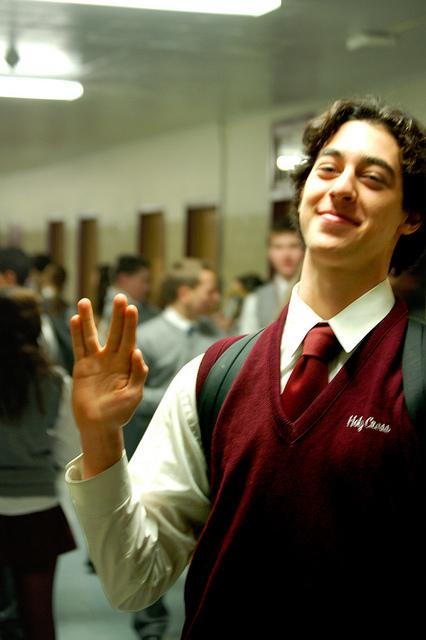What school does this boy attend?

Choices:
A) none
B) elementary
C) harvard
D) holy cross holy cross 